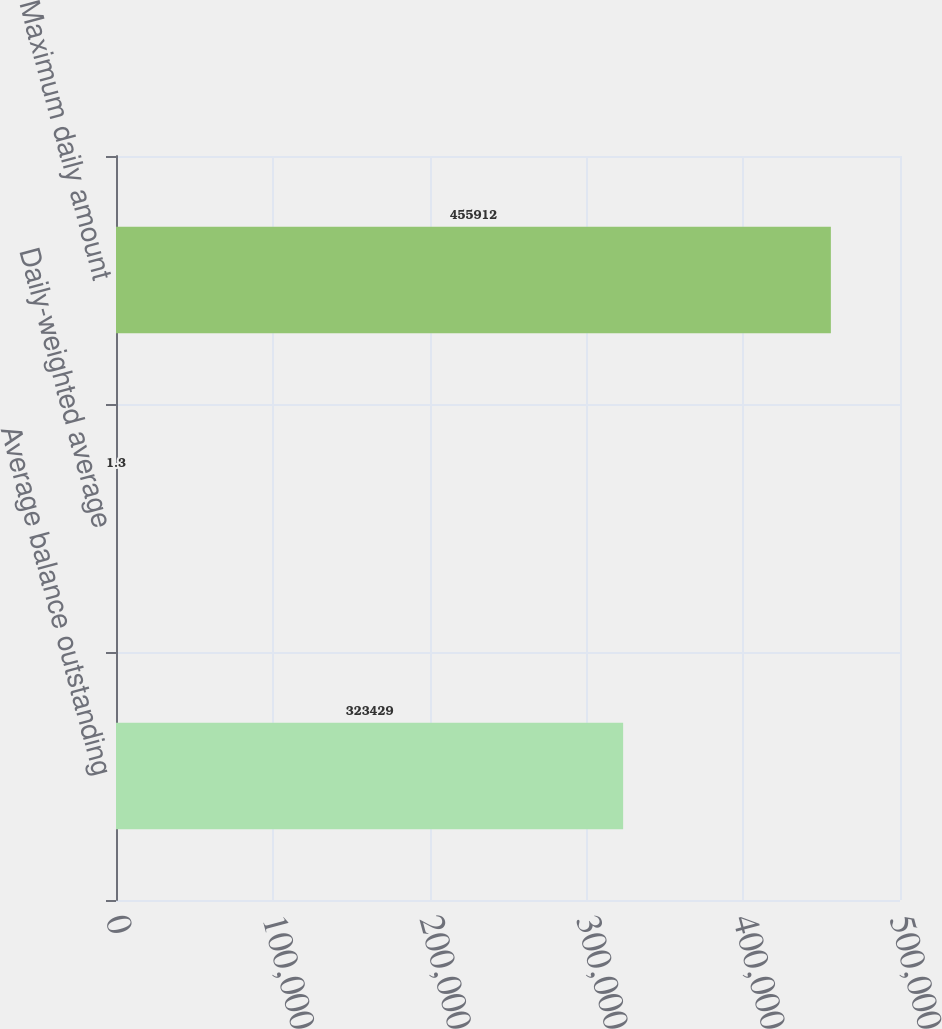Convert chart. <chart><loc_0><loc_0><loc_500><loc_500><bar_chart><fcel>Average balance outstanding<fcel>Daily-weighted average<fcel>Maximum daily amount<nl><fcel>323429<fcel>1.3<fcel>455912<nl></chart> 